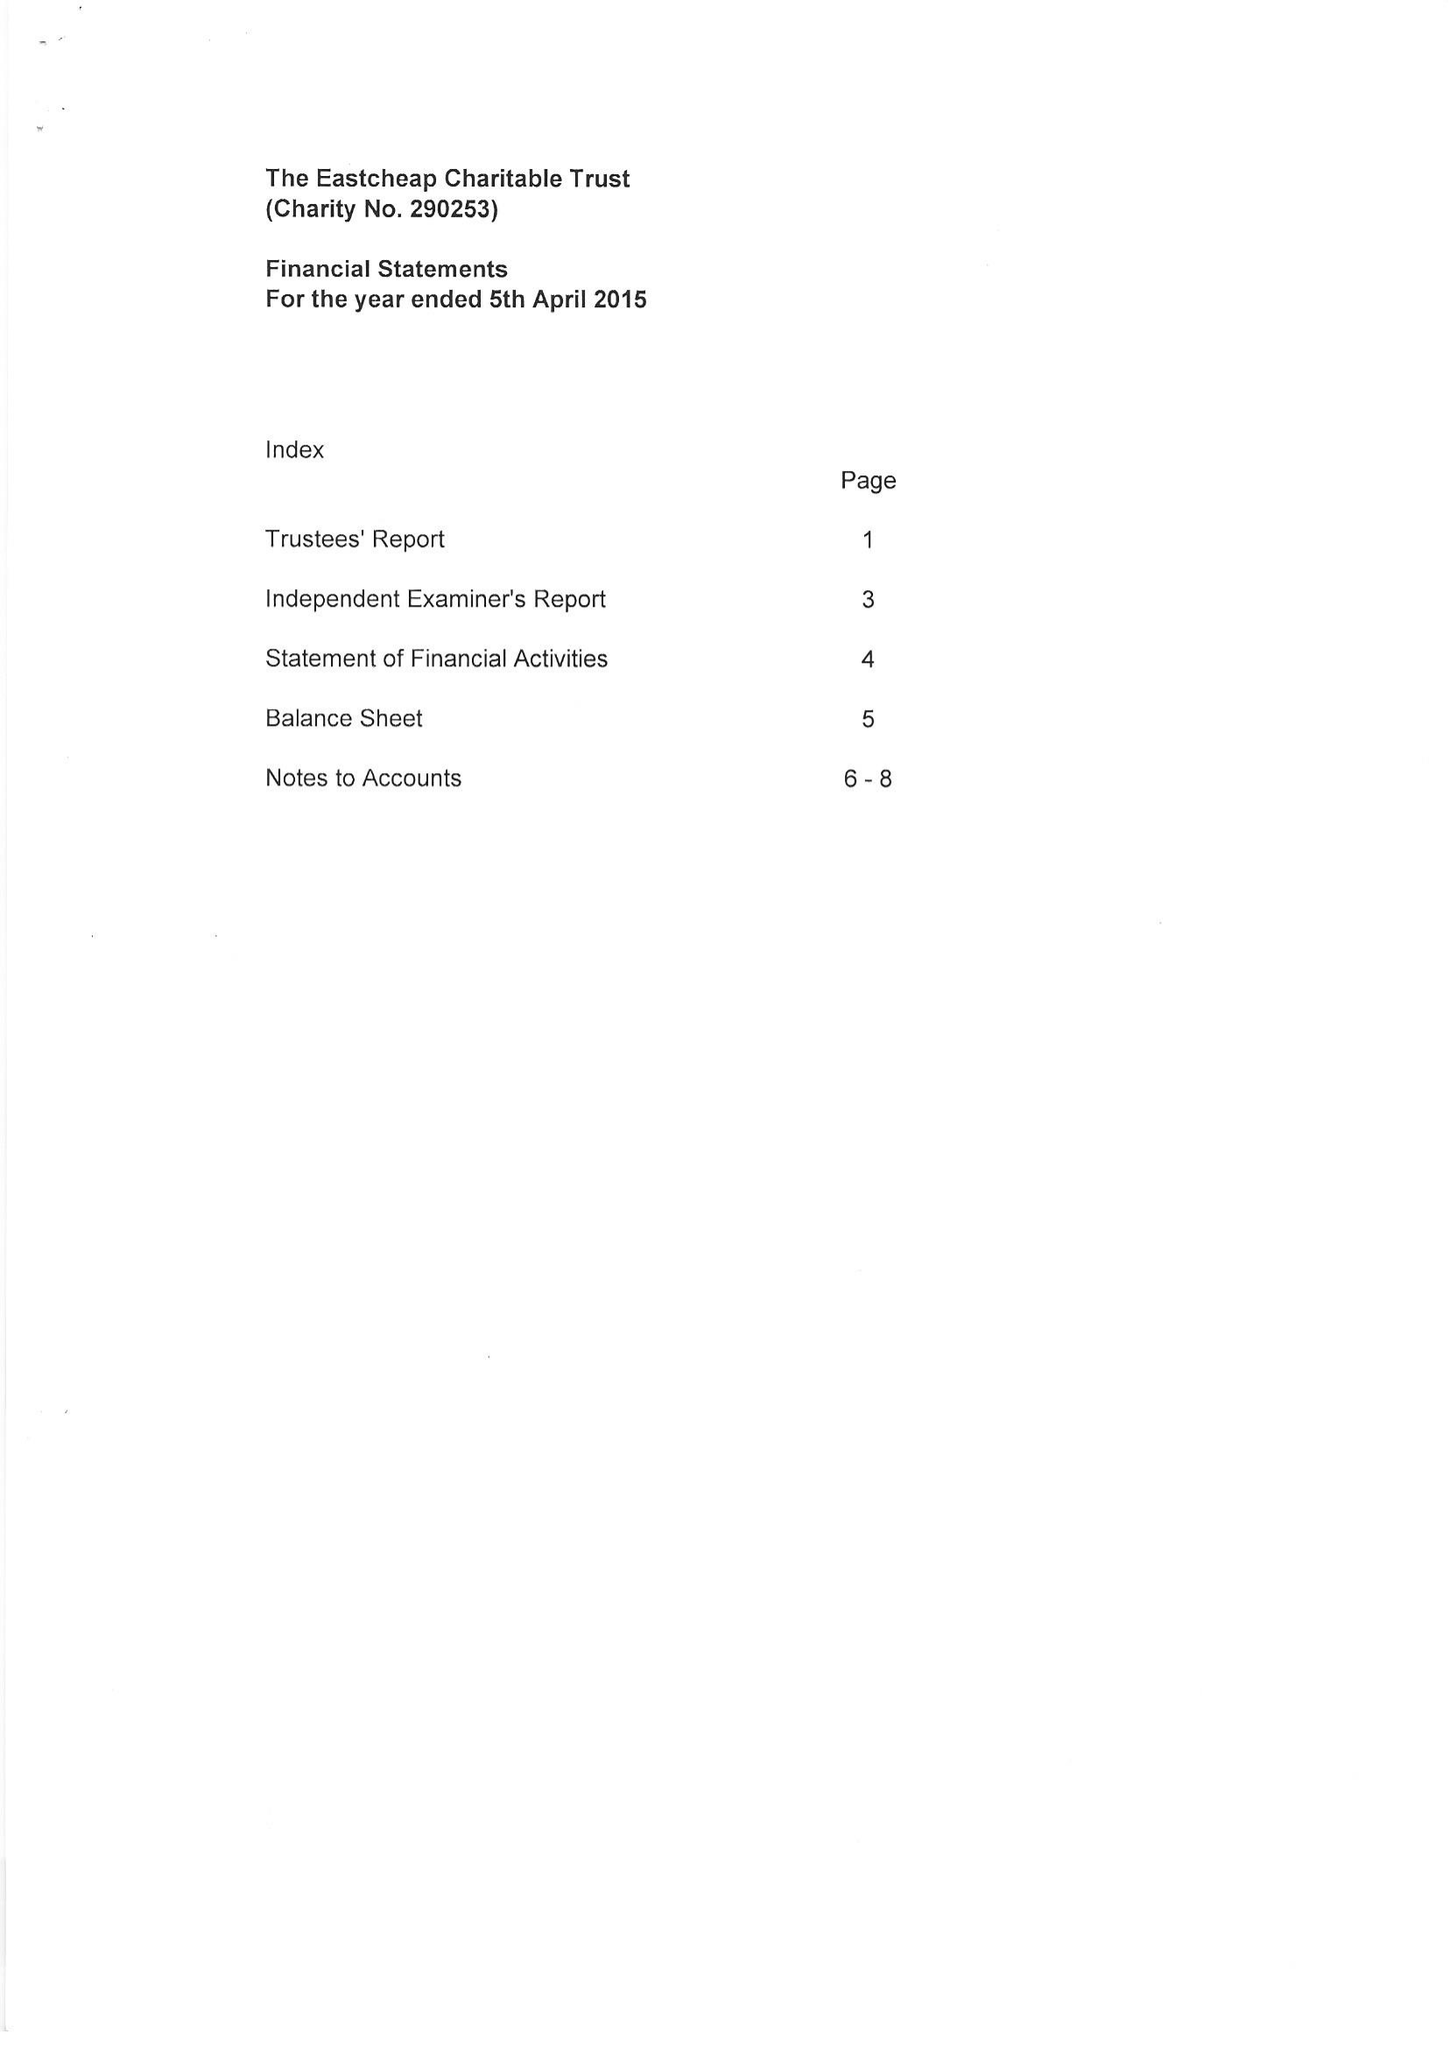What is the value for the address__street_line?
Answer the question using a single word or phrase. JUMPS ROAD 